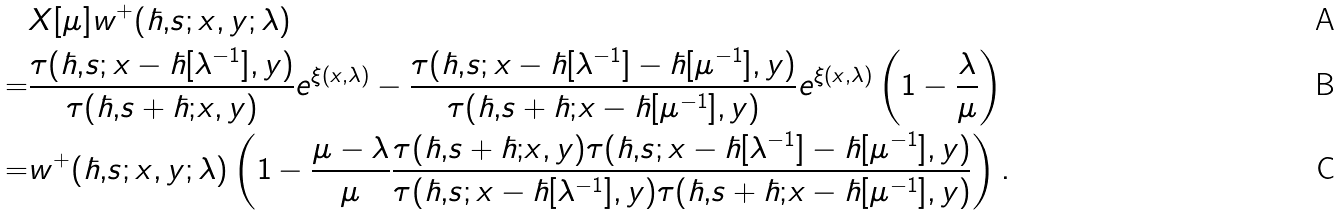<formula> <loc_0><loc_0><loc_500><loc_500>& X [ \mu ] w ^ { + } ( \hbar { , } s ; x , y ; \lambda ) \\ = & \frac { \tau ( \hbar { , } s ; x - \hbar { [ } \lambda ^ { - 1 } ] , y ) } { \tau ( \hbar { , } s + \hbar { ; } x , y ) } e ^ { \xi ( x , \lambda ) } - \frac { \tau ( \hbar { , } s ; x - \hbar { [ } \lambda ^ { - 1 } ] - \hbar { [ } \mu ^ { - 1 } ] , y ) } { \tau ( \hbar { , } s + \hbar { ; } x - \hbar { [ } \mu ^ { - 1 } ] , y ) } e ^ { \xi ( x , \lambda ) } \left ( 1 - \frac { \lambda } { \mu } \right ) \\ = & w ^ { + } ( \hbar { , } s ; x , y ; \lambda ) \left ( 1 - \frac { \mu - \lambda } { \mu } \frac { \tau ( \hbar { , } s + \hbar { ; } x , y ) \tau ( \hbar { , } s ; x - \hbar { [ } \lambda ^ { - 1 } ] - \hbar { [ } \mu ^ { - 1 } ] , y ) } { \tau ( \hbar { , } s ; x - \hbar { [ } \lambda ^ { - 1 } ] , y ) \tau ( \hbar { , } s + \hbar { ; } x - \hbar { [ } \mu ^ { - 1 } ] , y ) } \right ) .</formula> 